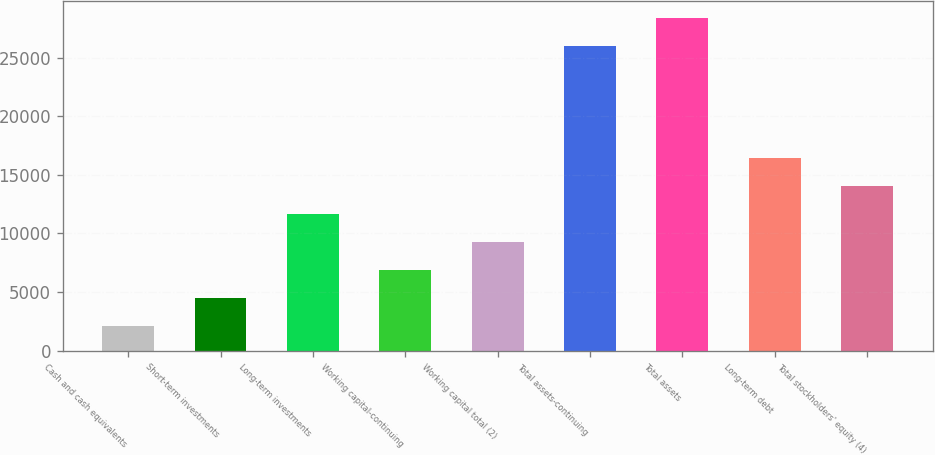Convert chart. <chart><loc_0><loc_0><loc_500><loc_500><bar_chart><fcel>Cash and cash equivalents<fcel>Short-term investments<fcel>Long-term investments<fcel>Working capital-continuing<fcel>Working capital total (2)<fcel>Total assets-continuing<fcel>Total assets<fcel>Long-term debt<fcel>Total stockholders' equity (4)<nl><fcel>2120<fcel>4506.6<fcel>11666.4<fcel>6893.2<fcel>9279.8<fcel>25986<fcel>28372.6<fcel>16439.6<fcel>14053<nl></chart> 